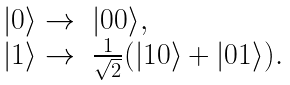<formula> <loc_0><loc_0><loc_500><loc_500>\begin{array} { l l } | 0 \rangle \rightarrow & | 0 0 \rangle , \\ | 1 \rangle \rightarrow & \frac { 1 } { \sqrt { 2 } } ( | 1 0 \rangle + | 0 1 \rangle ) . \end{array}</formula> 